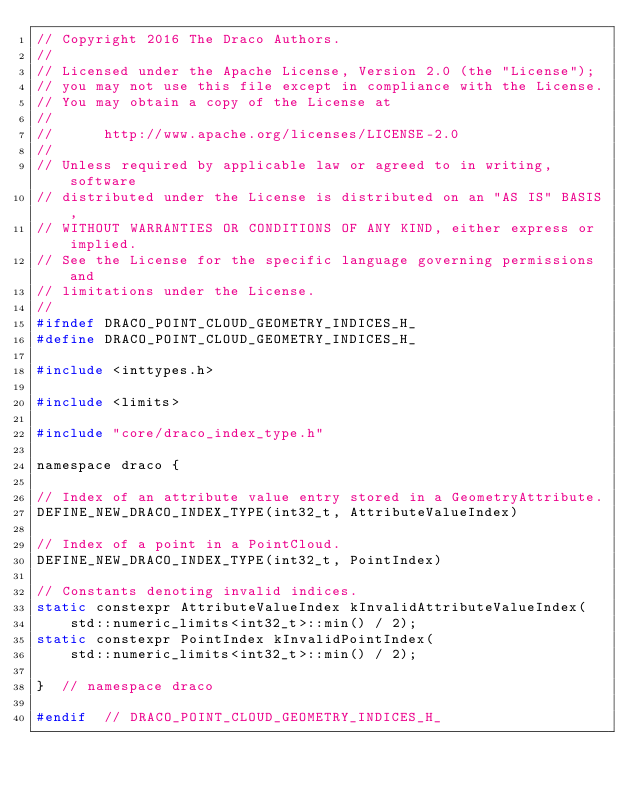Convert code to text. <code><loc_0><loc_0><loc_500><loc_500><_C_>// Copyright 2016 The Draco Authors.
//
// Licensed under the Apache License, Version 2.0 (the "License");
// you may not use this file except in compliance with the License.
// You may obtain a copy of the License at
//
//      http://www.apache.org/licenses/LICENSE-2.0
//
// Unless required by applicable law or agreed to in writing, software
// distributed under the License is distributed on an "AS IS" BASIS,
// WITHOUT WARRANTIES OR CONDITIONS OF ANY KIND, either express or implied.
// See the License for the specific language governing permissions and
// limitations under the License.
//
#ifndef DRACO_POINT_CLOUD_GEOMETRY_INDICES_H_
#define DRACO_POINT_CLOUD_GEOMETRY_INDICES_H_

#include <inttypes.h>

#include <limits>

#include "core/draco_index_type.h"

namespace draco {

// Index of an attribute value entry stored in a GeometryAttribute.
DEFINE_NEW_DRACO_INDEX_TYPE(int32_t, AttributeValueIndex)

// Index of a point in a PointCloud.
DEFINE_NEW_DRACO_INDEX_TYPE(int32_t, PointIndex)

// Constants denoting invalid indices.
static constexpr AttributeValueIndex kInvalidAttributeValueIndex(
    std::numeric_limits<int32_t>::min() / 2);
static constexpr PointIndex kInvalidPointIndex(
    std::numeric_limits<int32_t>::min() / 2);

}  // namespace draco

#endif  // DRACO_POINT_CLOUD_GEOMETRY_INDICES_H_
</code> 